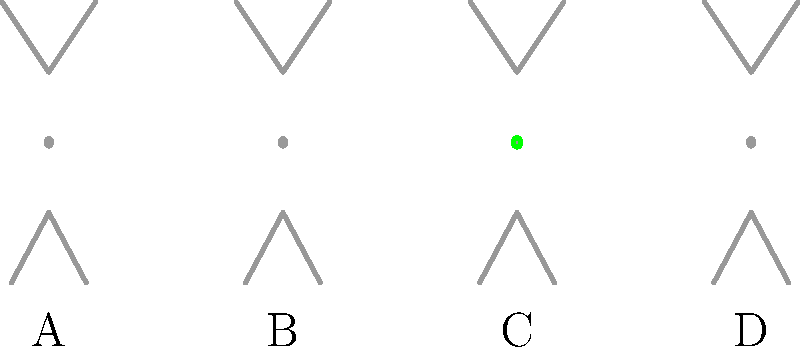Which silhouette represents the correct posture for the basic "T-position" in ballroom dancing, where the arms are extended horizontally and the feet are together? To identify the correct "T-position" in ballroom dancing, let's analyze each silhouette:

1. Silhouette A: The arms are not fully extended horizontally, and the legs appear slightly apart.
2. Silhouette B: The arms are positioned downward, not forming the characteristic "T" shape.
3. Silhouette C: The arms are extended horizontally, forming a perfect "T" shape, and the legs are together.
4. Silhouette D: The arms are raised above the horizontal position, not forming the correct "T" shape.

The "T-position" in ballroom dancing requires:
a) Arms extended horizontally to form a "T" shape with the body
b) Feet together to maintain balance and proper posture

Silhouette C is the only one that meets both these criteria, with the arms forming a perfect horizontal line and the legs appearing together.
Answer: C 